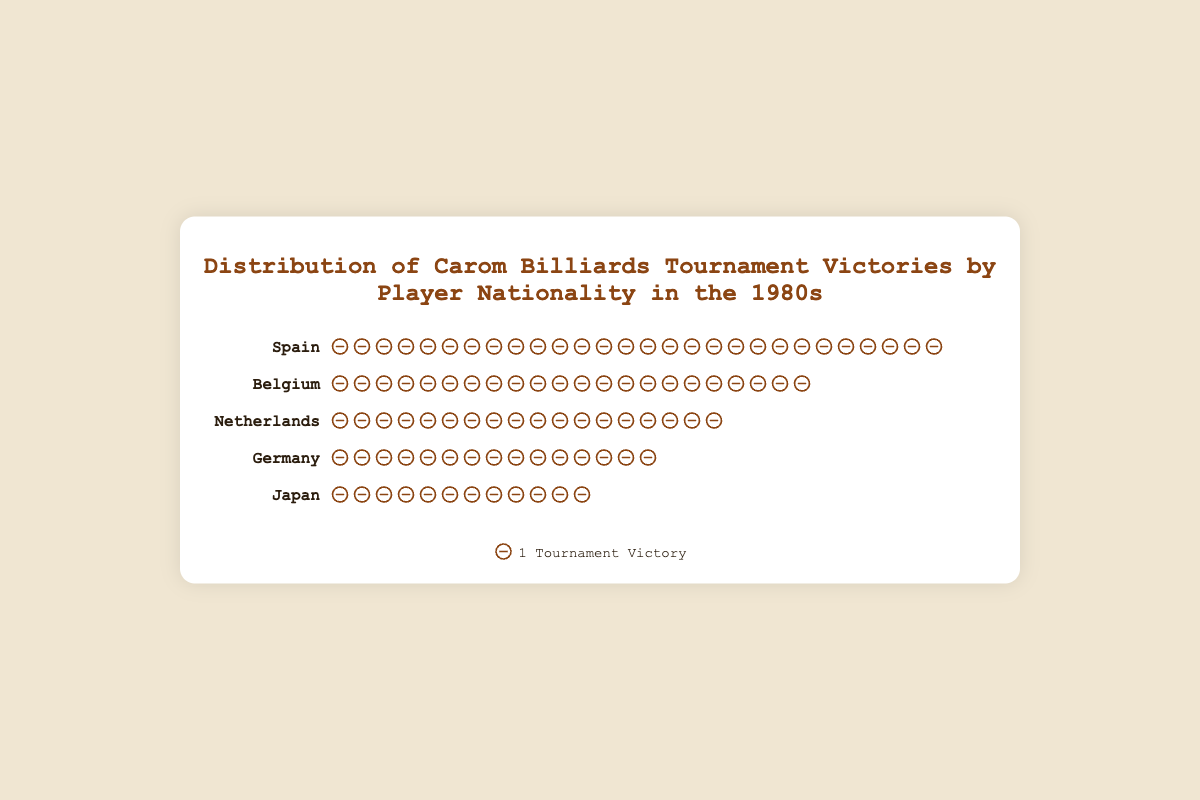Which country has the highest number of tournament victories? The country rows show victory icons representing tournament victories. Spain has the most icons in its row, indicating the highest number of victories.
Answer: Spain Which countries have more than 20 tournament victories? Counting the victory icons for each country, Spain has 28, and Belgium has 22, both above 20. The Netherlands, Germany, and Japan have fewer victories.
Answer: Spain, Belgium How many victories by players from Japan and Germany combined? Germany has 15 victories, and Japan has 12. Adding these together gives 15 + 12 = 27.
Answer: 27 Which country has the least number of tournament victories? By counting the victory icons for each country, Japan has the fewest icons, representing the lowest number of victories.
Answer: Japan Compare the number of victories between Belgium and Netherlands. Which country has more and by how many? Belgium has 22 victories, and the Netherlands has 18. Subtracting these gives 22 - 18 = 4.
Answer: Belgium, 4 How many players from Spain contributed to the victories? The data section lists the players from each country. Spain has contributions from 2 players: Avelino Rico and Jose Galvez.
Answer: 2 What is the total number of tournament victories displayed in the figure? Adding victories from all countries: 28 (Spain) + 22 (Belgium) + 18 (Netherlands) + 15 (Germany) + 12 (Japan) = 95.
Answer: 95 Who were the players representing the Netherlands? The data section lists the players from each country. For the Netherlands, it is Rini van Bracht and Christ van der Smissen.
Answer: Rini van Bracht, Christ van der Smissen Which countries had exactly 2 players each contributing to tournament victories? The data lists the players from each country. All listed countries (Spain, Belgium, Netherlands, Germany, Japan) had 2 players each.
Answer: Spain, Belgium, Netherlands, Germany, Japan How many more victories does Spain have compared to Japan? Spain has 28 victories, and Japan has 12. Subtracting these gives 28 - 12 = 16.
Answer: 16 